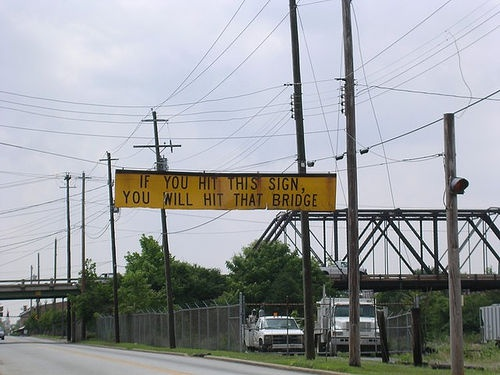Describe the objects in this image and their specific colors. I can see truck in lavender, gray, black, darkgray, and lightgray tones, truck in lavender, black, gray, and darkgray tones, car in lavender, darkgray, gray, black, and lightgray tones, traffic light in lavender, black, darkgray, gray, and lightgray tones, and car in lavender, gray, and black tones in this image. 